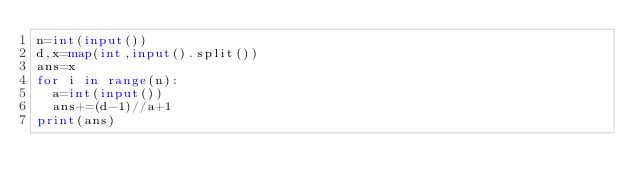Convert code to text. <code><loc_0><loc_0><loc_500><loc_500><_Python_>n=int(input())
d,x=map(int,input().split())
ans=x
for i in range(n):
  a=int(input())
  ans+=(d-1)//a+1
print(ans)
</code> 